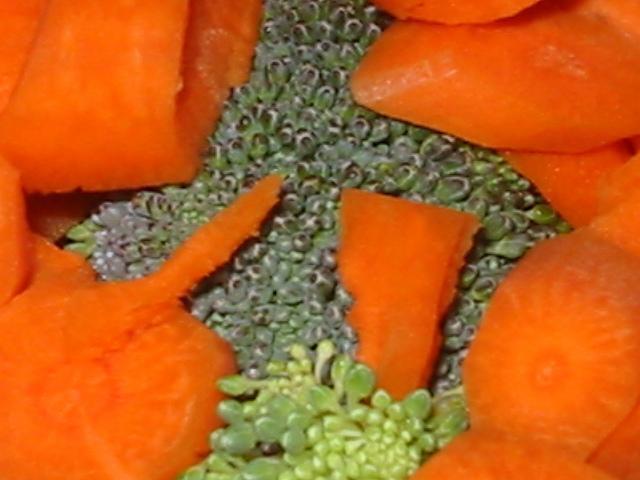How many carrots are there?
Give a very brief answer. 6. How many men are wearing black hats?
Give a very brief answer. 0. 